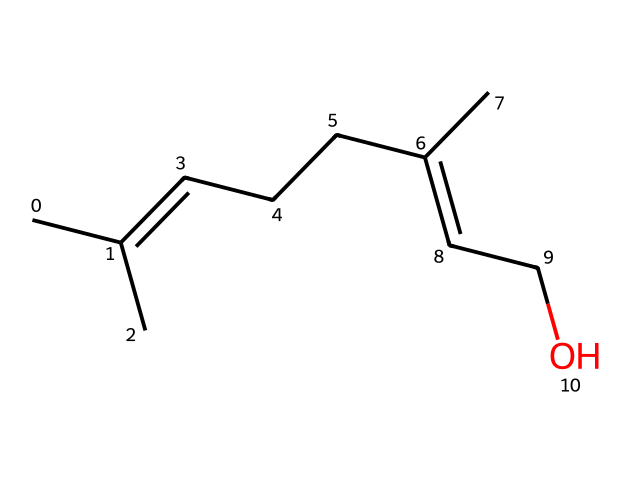What is the main functional group present in this chemical? The chemical structure shows an -OH group, indicating that it has an alcohol functional group.
Answer: alcohol How many carbon atoms are in the structure? By counting the carbon atoms in the SMILES representation, we find there are 10 carbon atoms altogether.
Answer: 10 What type of bond is primarily present in the chemical structure? The structure contains multiple single bonds and at least one double bond between the carbon atoms, indicating the presence of both types of bonds.
Answer: single and double What is the saturated/unsaturated nature of this chemical? The presence of a double bond in the structure indicates that the compound is unsaturated, as it cannot contain the maximum possible hydrogen atoms.
Answer: unsaturated Can you identify if this chemical is cyclic or acyclic? The representation shows a linear arrangement of atoms without any cycles or rings, indicating that it is acyclic.
Answer: acyclic What is the molecular formula based on the chemical structure? From counting the atoms from the SMILES, we can derive the molecular formula, which is C10H18O.
Answer: C10H18O 